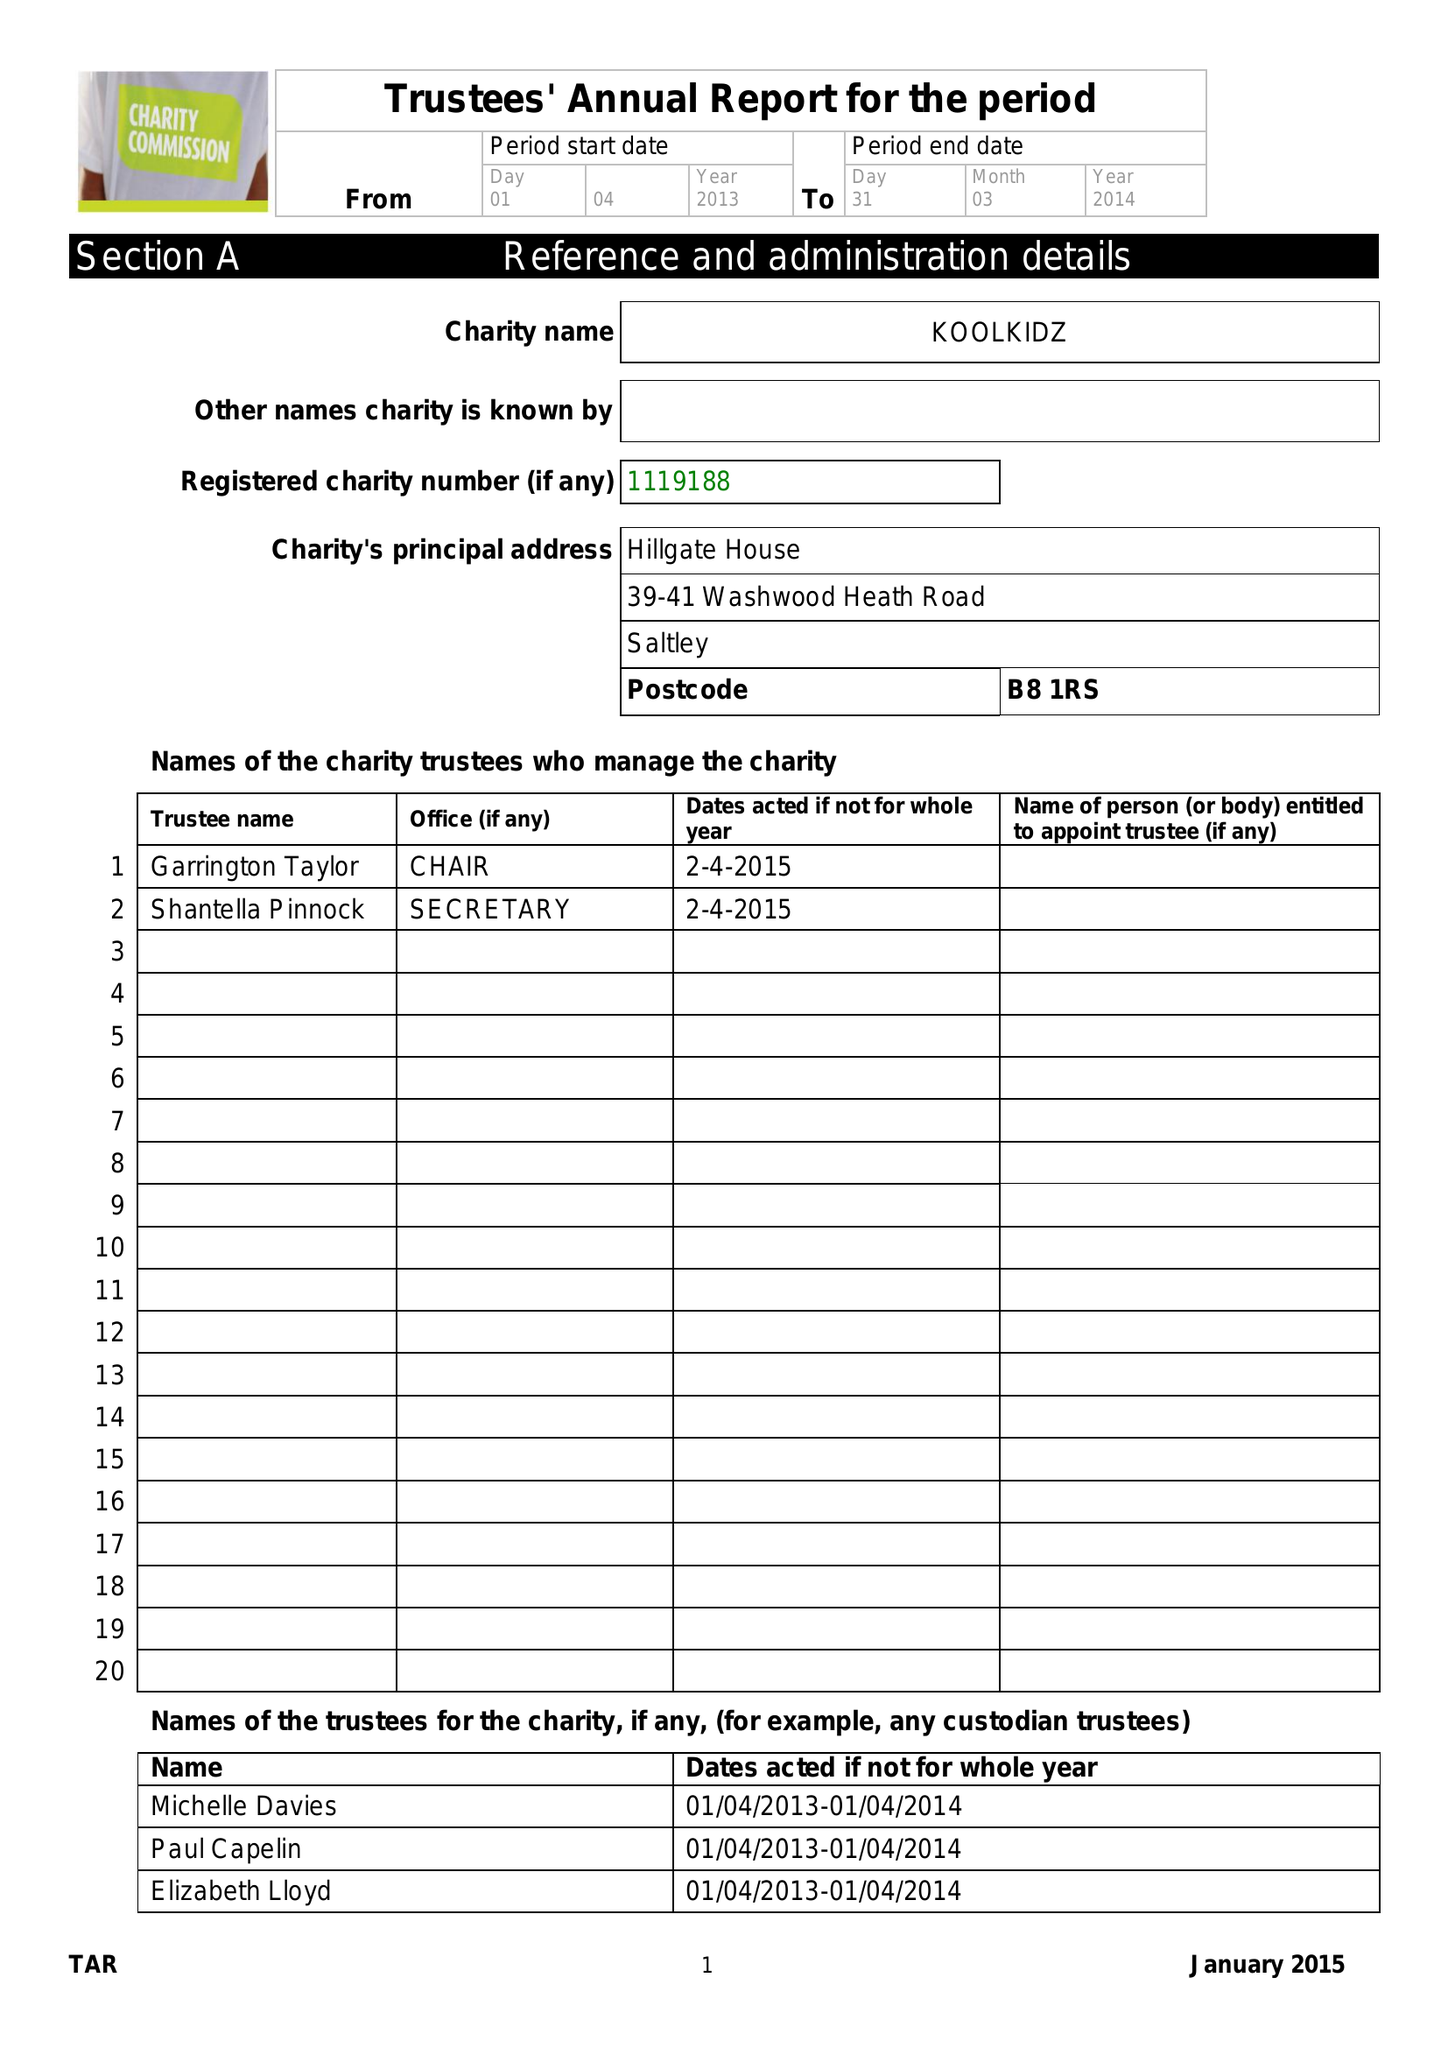What is the value for the charity_name?
Answer the question using a single word or phrase. Koolkidz Ltd. 